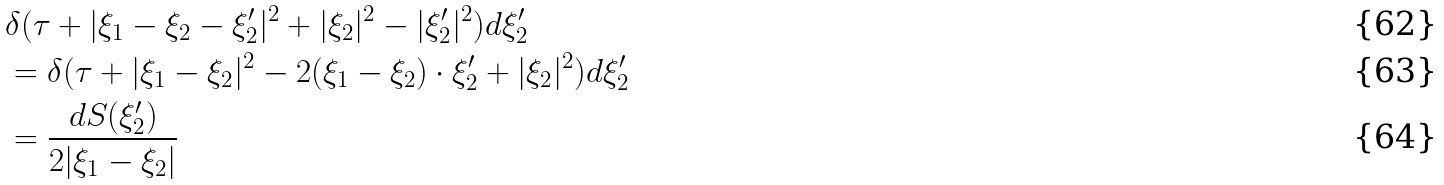Convert formula to latex. <formula><loc_0><loc_0><loc_500><loc_500>& \delta ( \tau + | \xi _ { 1 } - \xi _ { 2 } - \xi ^ { \prime } _ { 2 } | ^ { 2 } + | \xi _ { 2 } | ^ { 2 } - | \xi ^ { \prime } _ { 2 } | ^ { 2 } ) d \xi ^ { \prime } _ { 2 } \\ & = \delta ( \tau + | \xi _ { 1 } - \xi _ { 2 } | ^ { 2 } - 2 ( \xi _ { 1 } - \xi _ { 2 } ) \cdot \xi ^ { \prime } _ { 2 } + | \xi _ { 2 } | ^ { 2 } ) d \xi ^ { \prime } _ { 2 } \\ & = \frac { d S ( \xi ^ { \prime } _ { 2 } ) } { 2 | \xi _ { 1 } - \xi _ { 2 } | }</formula> 